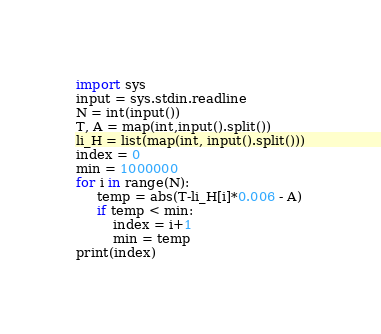Convert code to text. <code><loc_0><loc_0><loc_500><loc_500><_Python_>import sys
input = sys.stdin.readline
N = int(input())
T, A = map(int,input().split())
li_H = list(map(int, input().split()))
index = 0
min = 1000000
for i in range(N):
     temp = abs(T-li_H[i]*0.006 - A)
     if temp < min:
         index = i+1
         min = temp
print(index)</code> 